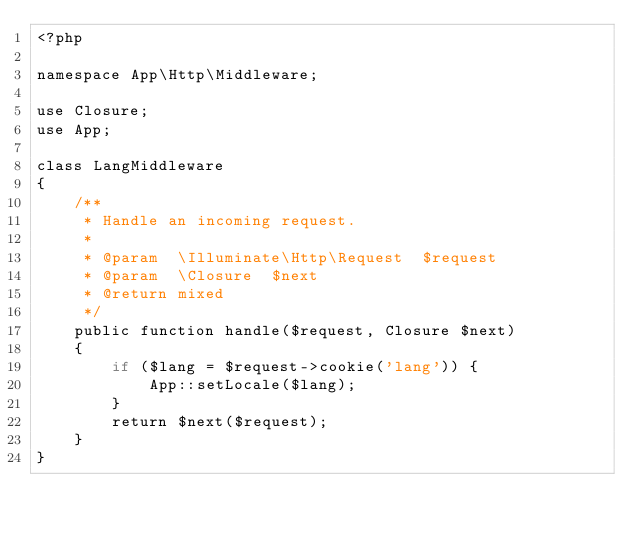<code> <loc_0><loc_0><loc_500><loc_500><_PHP_><?php

namespace App\Http\Middleware;

use Closure;
use App;

class LangMiddleware
{
    /**
     * Handle an incoming request.
     *
     * @param  \Illuminate\Http\Request  $request
     * @param  \Closure  $next
     * @return mixed
     */
    public function handle($request, Closure $next)
    {
        if ($lang = $request->cookie('lang')) {
            App::setLocale($lang);
        }
        return $next($request);
    }
}
</code> 